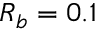Convert formula to latex. <formula><loc_0><loc_0><loc_500><loc_500>R _ { b } = 0 . 1</formula> 